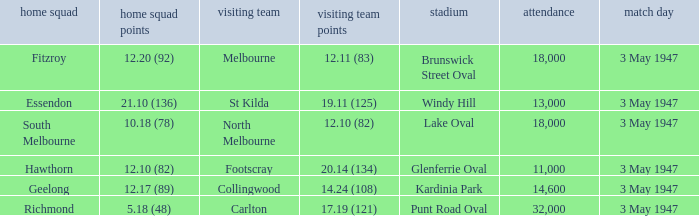In the game where the away team score is 17.19 (121), who was the away team? Carlton. 